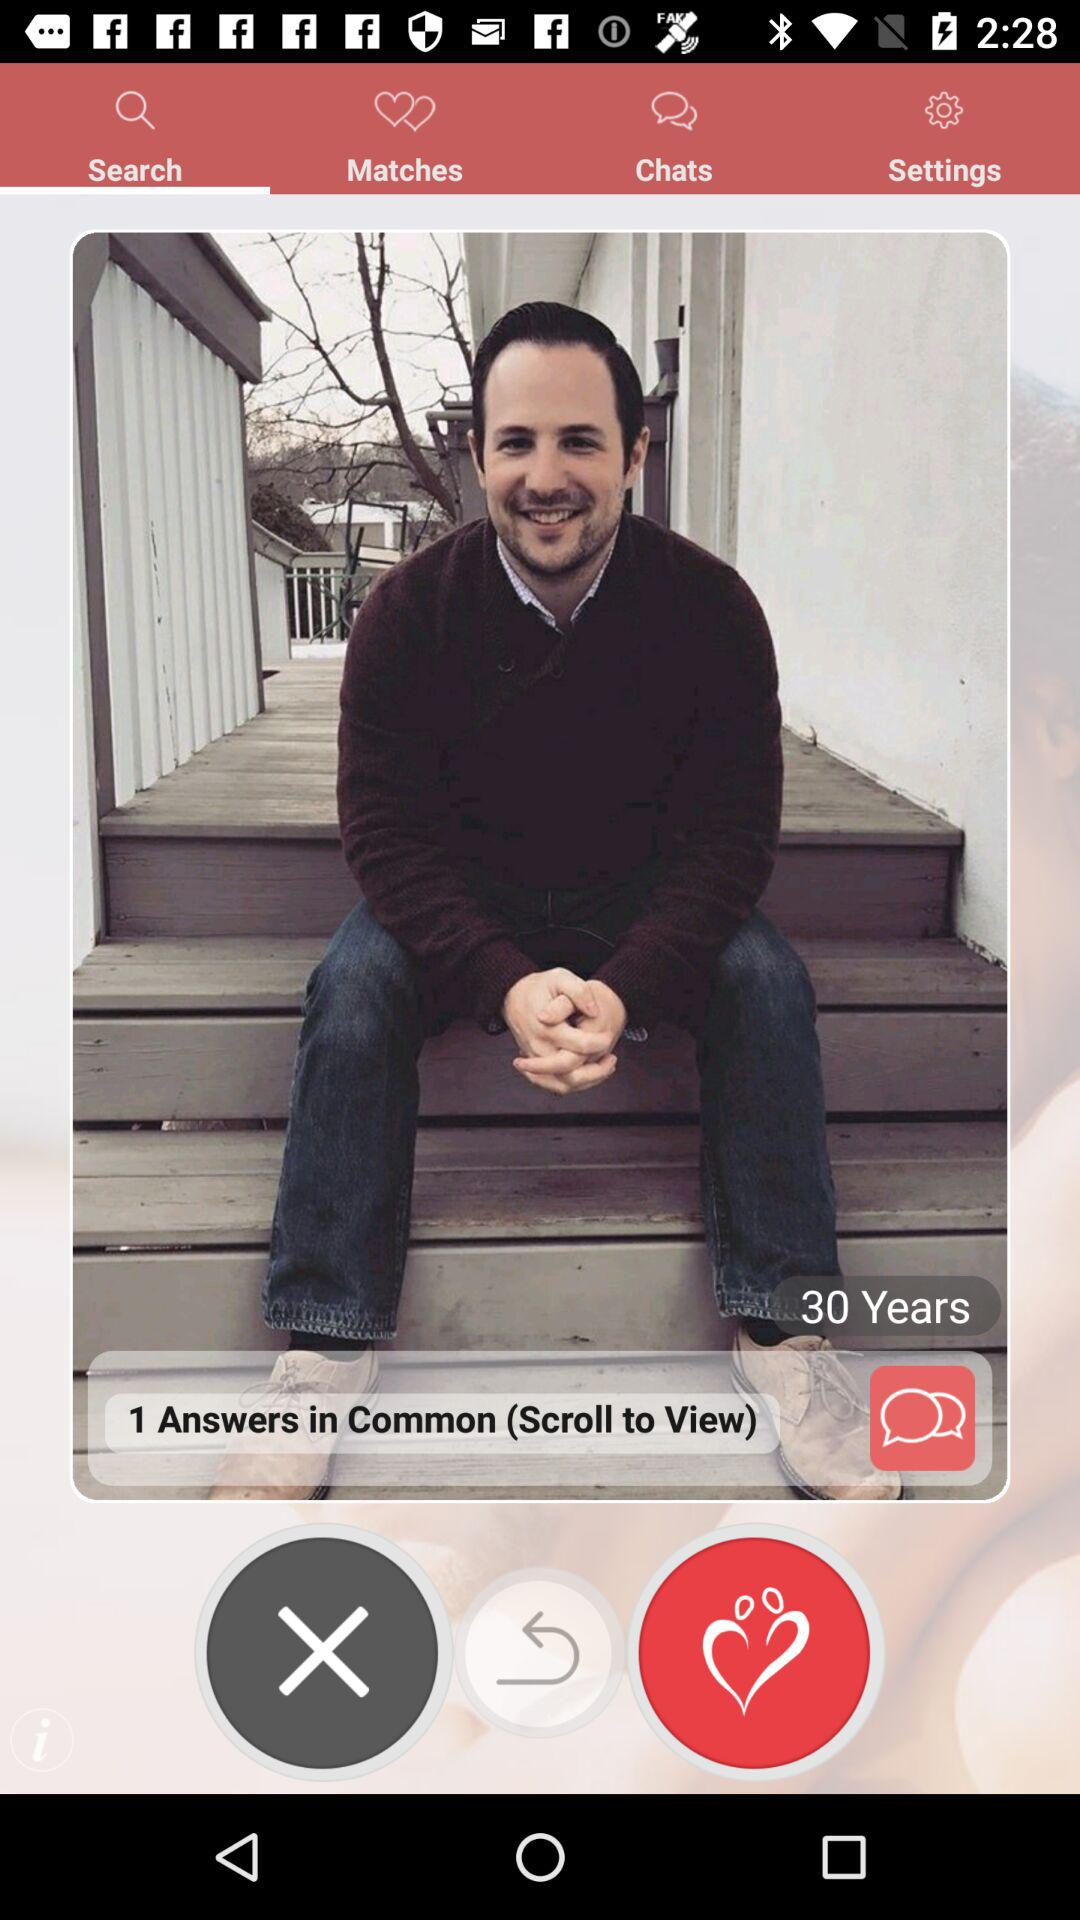Which tab is selected? The selected tab is "Search". 